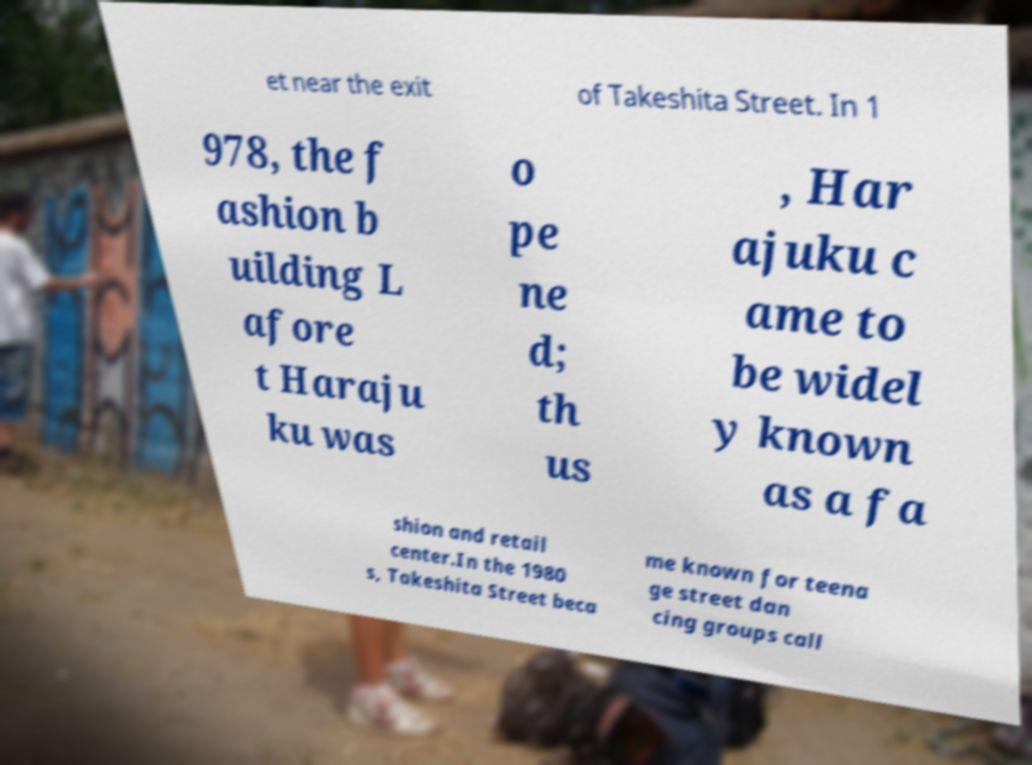Could you extract and type out the text from this image? et near the exit of Takeshita Street. In 1 978, the f ashion b uilding L afore t Haraju ku was o pe ne d; th us , Har ajuku c ame to be widel y known as a fa shion and retail center.In the 1980 s, Takeshita Street beca me known for teena ge street dan cing groups call 